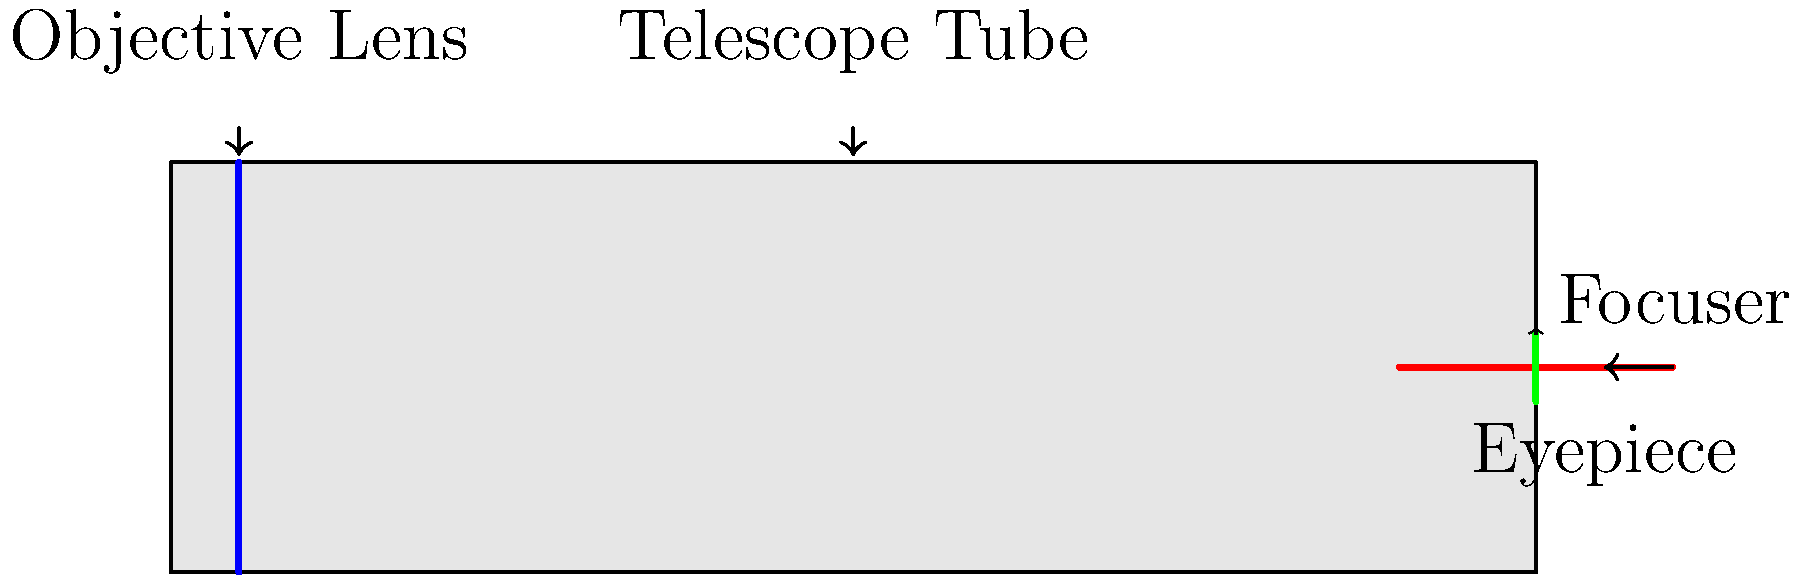If a telescope were a blockbuster movie, which part would be the "star" that captures all the light and attention, much like how certain actors draw audiences to the big screen? Let's break down the roles of each part in our telescope "movie":

1. Telescope Tube: This is like the set or stage where all the action happens. It provides structure and support but isn't the main attraction.

2. Focuser: This is similar to the camera operator, adjusting the focus to get the perfect shot. It's crucial but works behind the scenes.

3. Eyepiece: This is like the screen where we see the final product. It's important for the viewer's experience but doesn't create the image itself.

4. Objective Lens: This is our "star." Just as a famous actor draws in the audience and is central to the movie's success, the objective lens is the primary component that gathers light from distant objects.

The objective lens, typically the largest lens in the telescope, collects and focuses light from celestial objects. Its size directly affects the telescope's light-gathering ability and resolving power. Without it, we wouldn't have an image to view, just as a movie wouldn't exist without its lead actor.
Answer: Objective Lens 